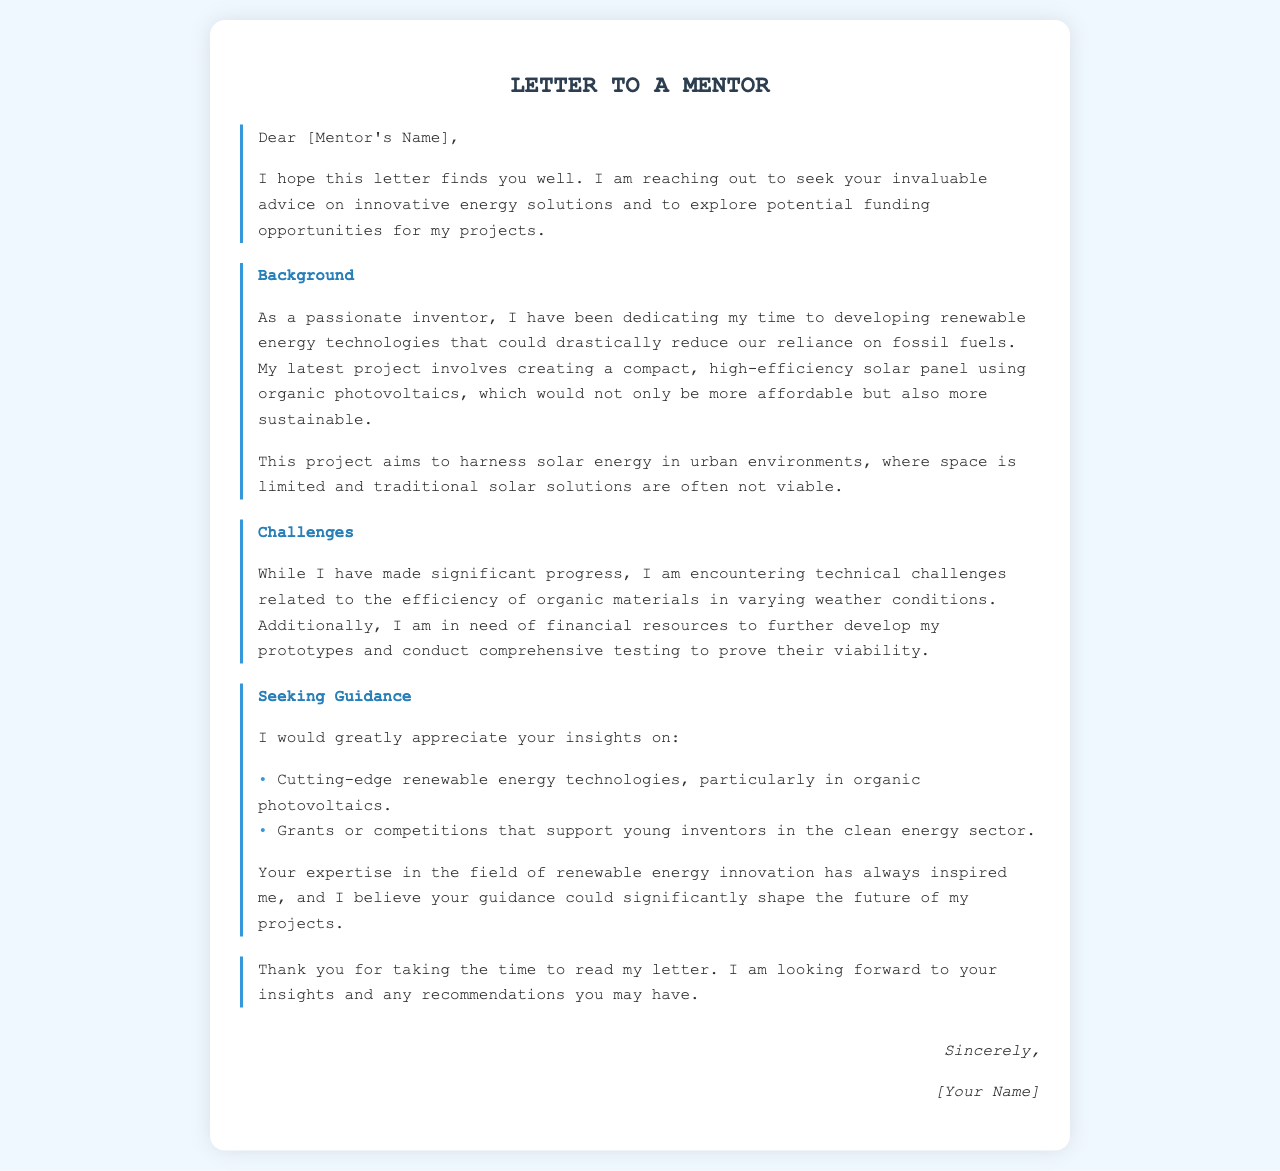What is the primary focus of the letter? The letter focuses on seeking advice and funding opportunities related to renewable energy technology.
Answer: renewable energy technology Who is the intended recipient of the letter? The intended recipient of the letter is mentioned at the beginning as a mentor.
Answer: mentor What type of solar technology is the inventor working on? The inventor is developing a compact, high-efficiency solar panel using organic photovoltaics.
Answer: organic photovoltaics What is one key challenge mentioned in the letter? The letter mentions technical challenges related to the efficiency of organic materials in varying weather conditions.
Answer: efficiency of organic materials What does the inventor appreciate from the mentor? The inventor appreciates insights on renewable energy technologies and funding opportunities.
Answer: insights on renewable energy technologies What does the inventor need financial resources for? The inventor needs financial resources to further develop prototypes and conduct comprehensive testing.
Answer: develop prototypes What type of competitions is the inventor seeking information about? The inventor is seeking information about grants or competitions that support young inventors in the clean energy sector.
Answer: grants or competitions How does the inventor describe their latest project? The inventor describes the project as affordable and sustainable.
Answer: affordable and sustainable What does the inventor hope to achieve with their project? The inventor hopes to harness solar energy in urban environments.
Answer: harness solar energy in urban environments 